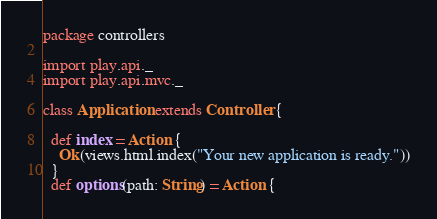<code> <loc_0><loc_0><loc_500><loc_500><_Scala_>package controllers

import play.api._
import play.api.mvc._

class Application extends Controller {

  def index = Action {
    Ok(views.html.index("Your new application is ready."))
  }
  def options(path: String) = Action {</code> 